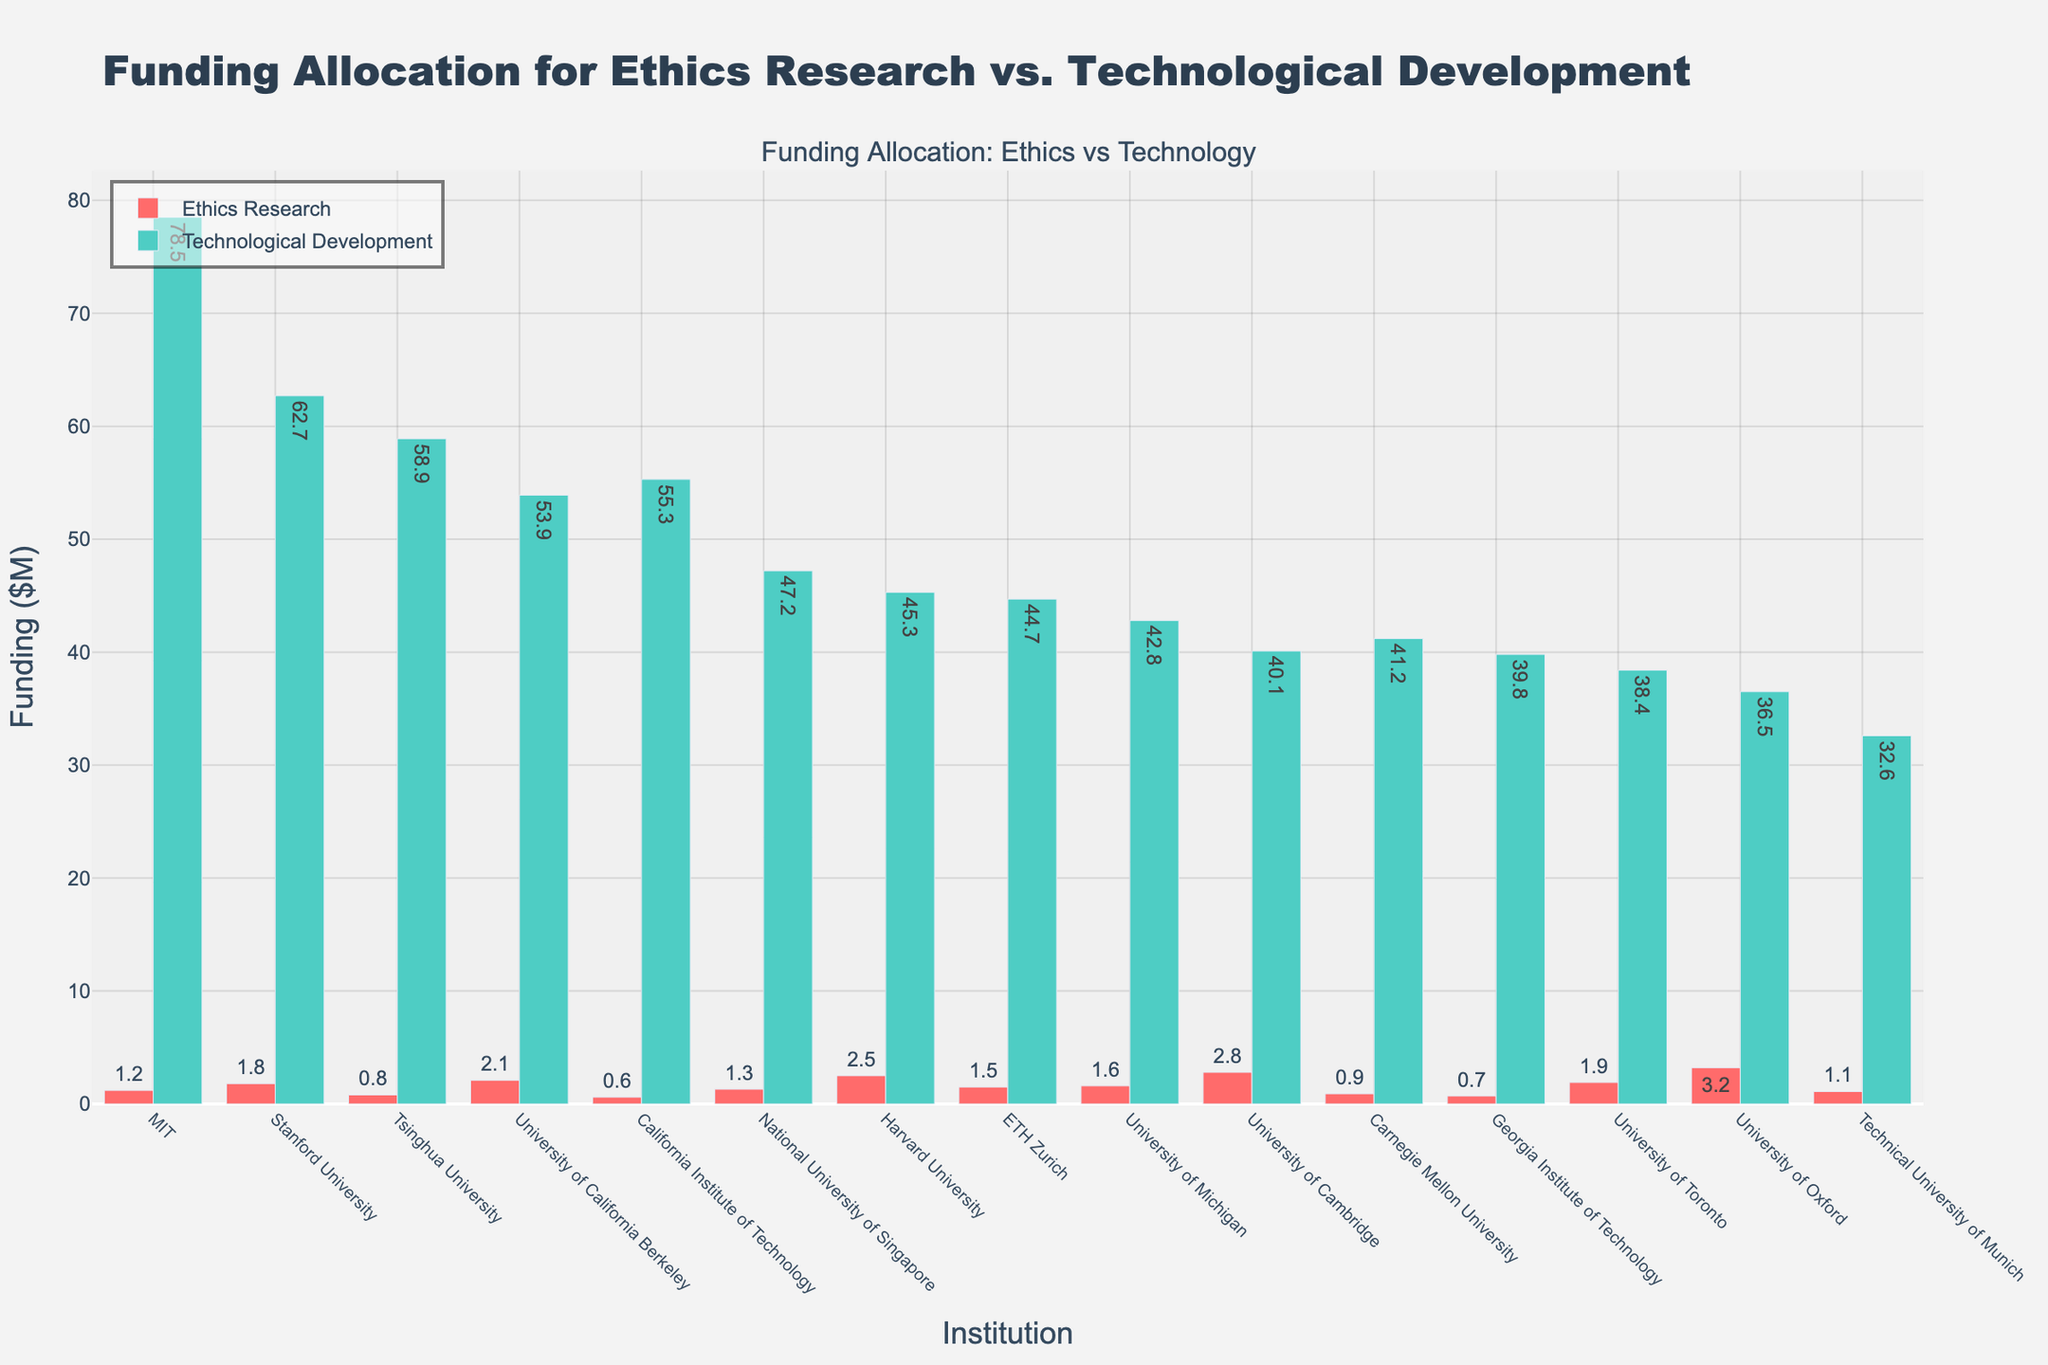Which institution has the highest funding for technological development? Observing the heights of the green bars, MIT has the highest with $78.5M in funding for technological development.
Answer: MIT What is the total funding for ethics research and technological development in Stanford University? Stanford University has $1.8M for ethics research and $62.7M for technological development. Summing these gives $1.8M + $62.7M = $64.5M.
Answer: $64.5M Which institution has the largest gap between funding for technological development and ethics research, and what is the gap? MIT has $78.5M in technological development funding and $1.2M in ethics research funding. The gap is $78.5M - $1.2M = $77.3M.
Answer: MIT, $77.3M Is there any institution with greater funding in ethics research compared to technological development? Observing the bars, University of Oxford is the only institution where the red bar (ethics research) is higher than the green bar (technological development) with $3.2M vs $36.5M.
Answer: University of Oxford What is the average funding for ethics research across all institutions? Summing the ethics research funding of all institutions: $2.5M + $1.8M + $1.2M + $2.1M + $0.9M + $0.7M + $3.2M + $1.5M + $0.6M + $2.8M + $1.1M + $1.3M + $1.9M + $0.8M + $1.6M = $24M. Divide by the number of institutions (15), $24M / 15 = $1.6M.
Answer: $1.6M Which institution receives the least funding for technological development, and how much is it? Observing the heights of the green bars, Technical University of Munich has the least with $32.6M in funding for technological development.
Answer: Technical University of Munich, $32.6M Compare the funding for ethics research between Harvard University and the University of Cambridge. Which receives more, and by how much? Harvard University has $2.5M for ethics research while the University of Cambridge has $2.8M. The difference is $2.8M - $2.5M = $0.3M.
Answer: University of Cambridge, $0.3M What proportion of University of Michigan's total funding is allocated to ethics research? University of Michigan's funding for ethics research is $1.6M and for technological development is $42.8M. Total funding is $1.6M + $42.8M = $44.4M. The proportion is $1.6M / $44.4M = 0.036 or 3.6%.
Answer: 3.6% Which institution has the closest funding amounts for ethics research and technological development, and what are those amounts? University of Oxford has $3.2M for ethics research and $36.5M for technological development, showing the smallest relative difference between the funding amounts.
Answer: University of Oxford, $3.2M and $36.5M 